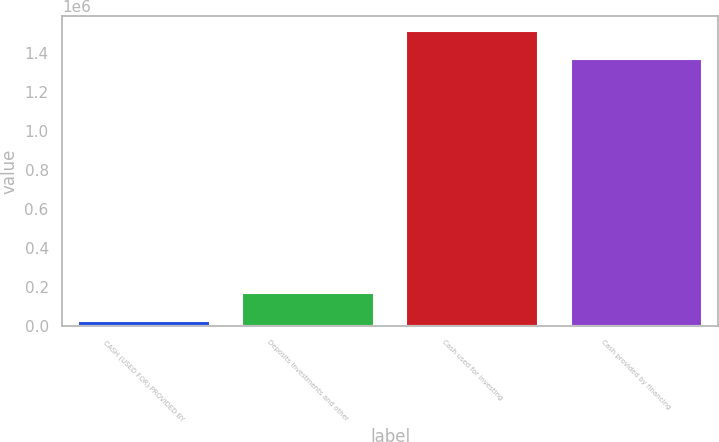Convert chart to OTSL. <chart><loc_0><loc_0><loc_500><loc_500><bar_chart><fcel>CASH (USED FOR) PROVIDED BY<fcel>Deposits investments and other<fcel>Cash used for investing<fcel>Cash provided by financing<nl><fcel>26070<fcel>167993<fcel>1.51508e+06<fcel>1.37315e+06<nl></chart> 